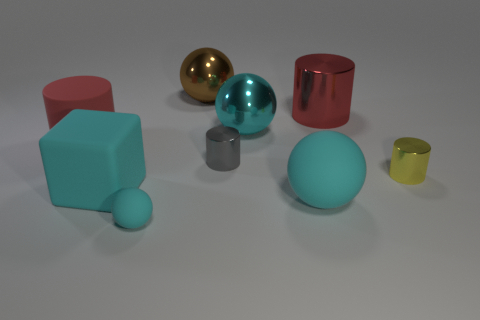Subtract all cyan spheres. How many were subtracted if there are1cyan spheres left? 2 Subtract all large spheres. How many spheres are left? 1 Subtract all brown balls. How many balls are left? 3 Subtract 1 cubes. How many cubes are left? 0 Add 1 large green metallic blocks. How many objects exist? 10 Subtract all brown cylinders. How many brown balls are left? 1 Subtract 0 yellow blocks. How many objects are left? 9 Subtract all cylinders. How many objects are left? 5 Subtract all blue cylinders. Subtract all gray cubes. How many cylinders are left? 4 Subtract all red cylinders. Subtract all purple matte cylinders. How many objects are left? 7 